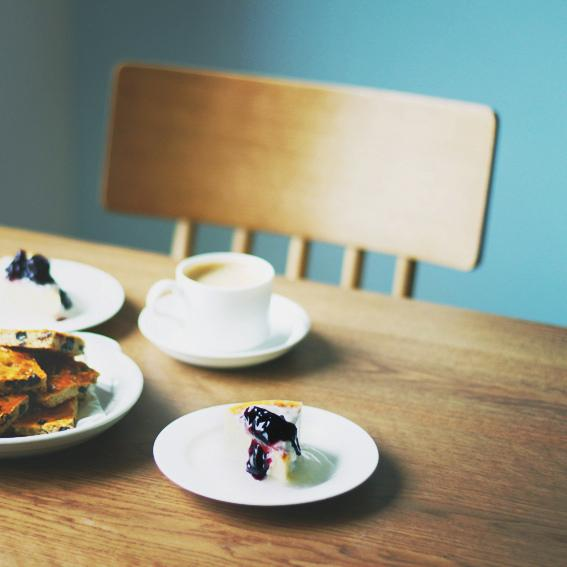What meal is being served? Please explain your reasoning. afternoon tea. Thsi is a tea cup and tea is being served. 